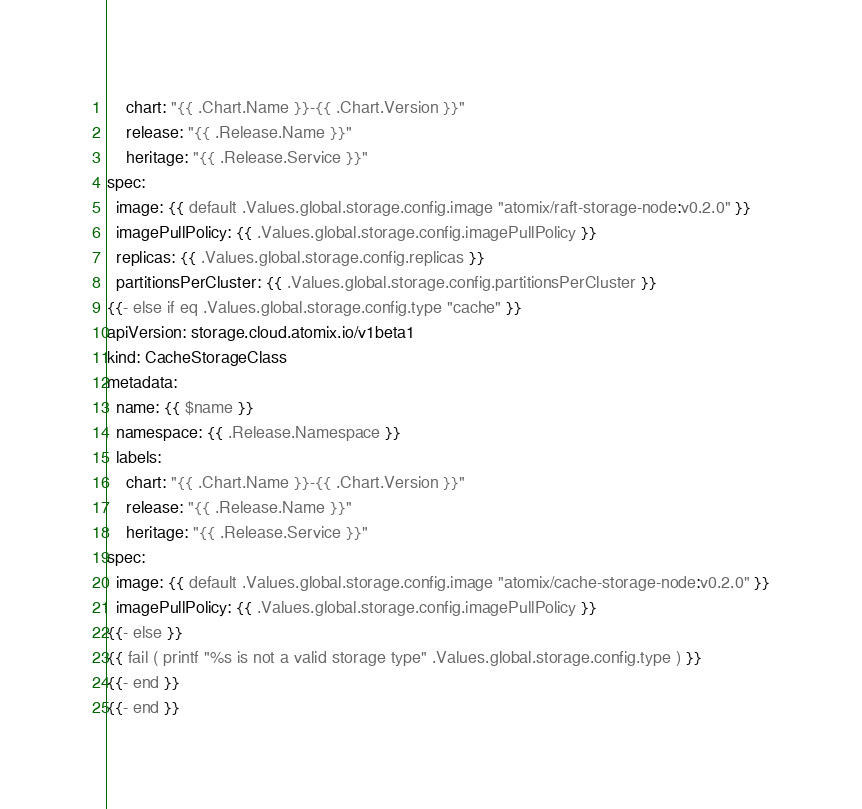<code> <loc_0><loc_0><loc_500><loc_500><_YAML_>    chart: "{{ .Chart.Name }}-{{ .Chart.Version }}"
    release: "{{ .Release.Name }}"
    heritage: "{{ .Release.Service }}"
spec:
  image: {{ default .Values.global.storage.config.image "atomix/raft-storage-node:v0.2.0" }}
  imagePullPolicy: {{ .Values.global.storage.config.imagePullPolicy }}
  replicas: {{ .Values.global.storage.config.replicas }}
  partitionsPerCluster: {{ .Values.global.storage.config.partitionsPerCluster }}
{{- else if eq .Values.global.storage.config.type "cache" }}
apiVersion: storage.cloud.atomix.io/v1beta1
kind: CacheStorageClass
metadata:
  name: {{ $name }}
  namespace: {{ .Release.Namespace }}
  labels:
    chart: "{{ .Chart.Name }}-{{ .Chart.Version }}"
    release: "{{ .Release.Name }}"
    heritage: "{{ .Release.Service }}"
spec:
  image: {{ default .Values.global.storage.config.image "atomix/cache-storage-node:v0.2.0" }}
  imagePullPolicy: {{ .Values.global.storage.config.imagePullPolicy }}
{{- else }}
{{ fail ( printf "%s is not a valid storage type" .Values.global.storage.config.type ) }}
{{- end }}
{{- end }}</code> 